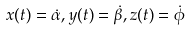Convert formula to latex. <formula><loc_0><loc_0><loc_500><loc_500>x ( t ) = \dot { \alpha } , y ( t ) = \dot { \beta } , z ( t ) = \dot { \phi }</formula> 